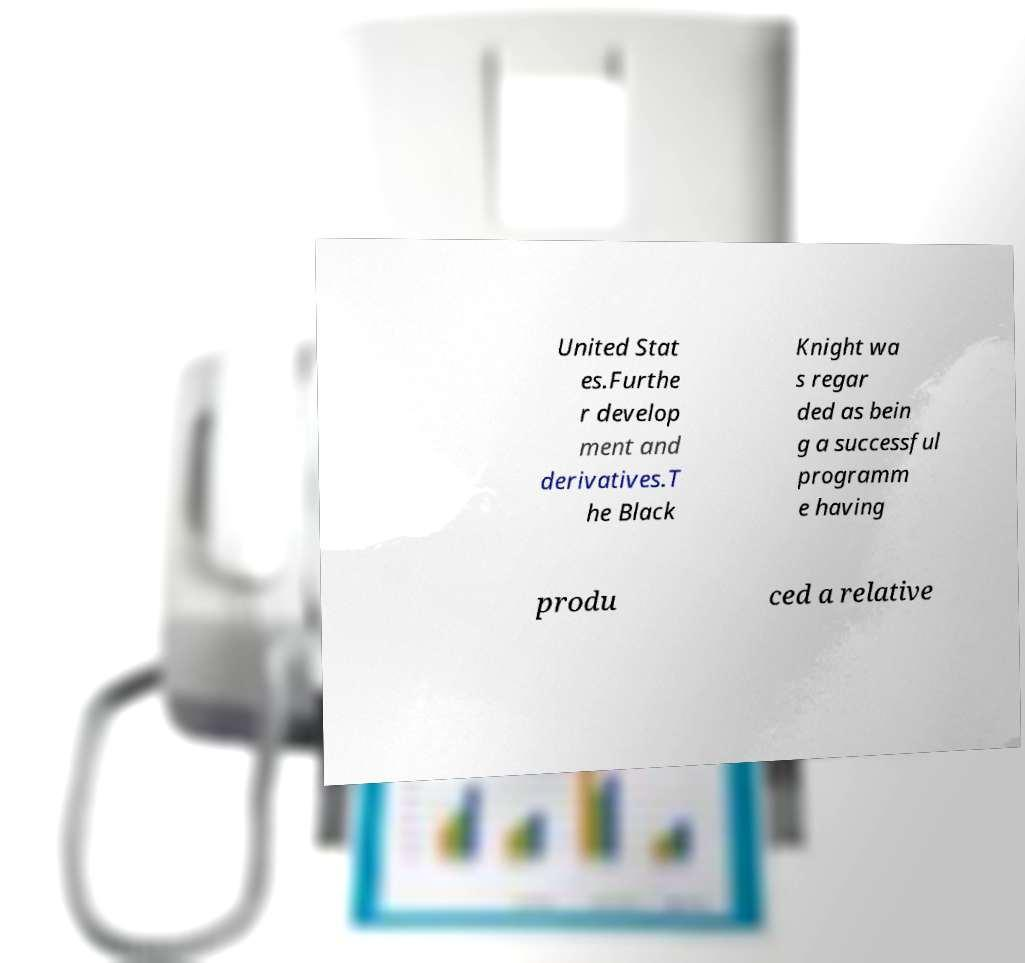What messages or text are displayed in this image? I need them in a readable, typed format. United Stat es.Furthe r develop ment and derivatives.T he Black Knight wa s regar ded as bein g a successful programm e having produ ced a relative 